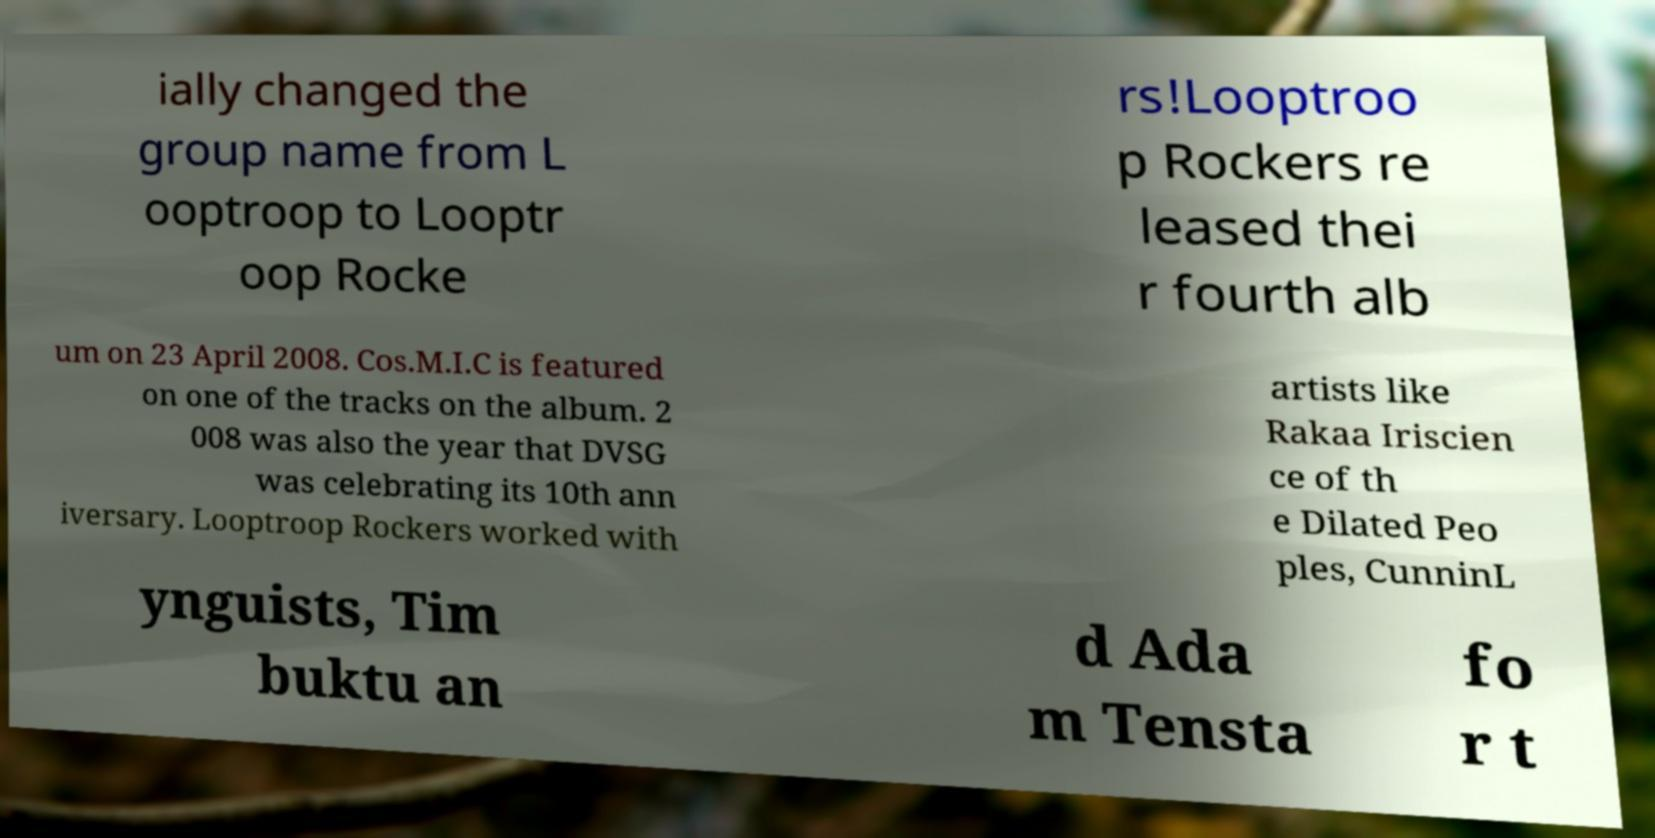I need the written content from this picture converted into text. Can you do that? ially changed the group name from L ooptroop to Looptr oop Rocke rs!Looptroo p Rockers re leased thei r fourth alb um on 23 April 2008. Cos.M.I.C is featured on one of the tracks on the album. 2 008 was also the year that DVSG was celebrating its 10th ann iversary. Looptroop Rockers worked with artists like Rakaa Iriscien ce of th e Dilated Peo ples, CunninL ynguists, Tim buktu an d Ada m Tensta fo r t 